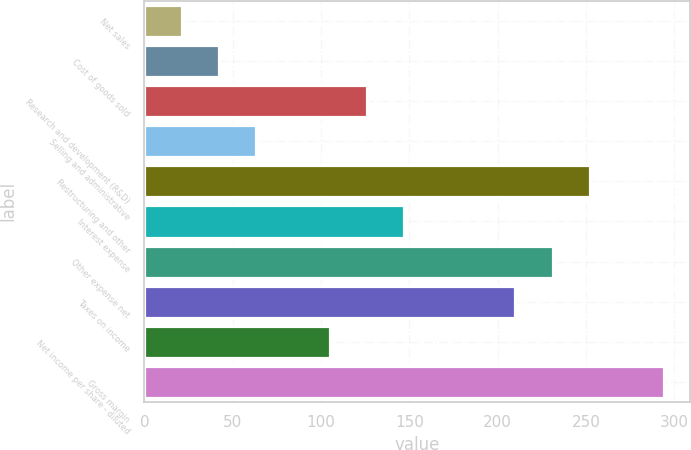Convert chart. <chart><loc_0><loc_0><loc_500><loc_500><bar_chart><fcel>Net sales<fcel>Cost of goods sold<fcel>Research and development (R&D)<fcel>Selling and administrative<fcel>Restructuring and other<fcel>Interest expense<fcel>Other expense net<fcel>Taxes on income<fcel>Net income per share - diluted<fcel>Gross margin<nl><fcel>21.18<fcel>42.16<fcel>126.08<fcel>63.14<fcel>251.96<fcel>147.06<fcel>230.98<fcel>210<fcel>105.1<fcel>293.92<nl></chart> 